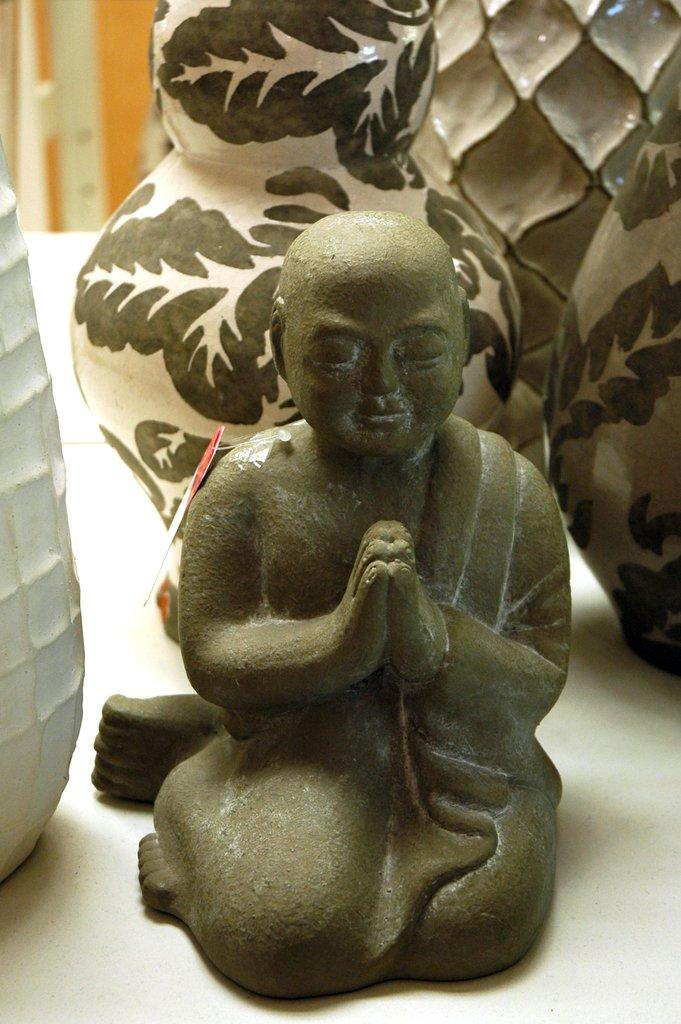What is the main subject in the image? There is a statue in the image. What can be seen behind the statue? There are flower pots behind the statue. What is the color of the surface behind the statue? The surface behind the statue is white in color. What type of insect is crawling on the statue's head in the image? There are no insects visible on the statue's head in the image. Is the statue wearing a cap in the image? There is no cap visible on the statue in the image. 